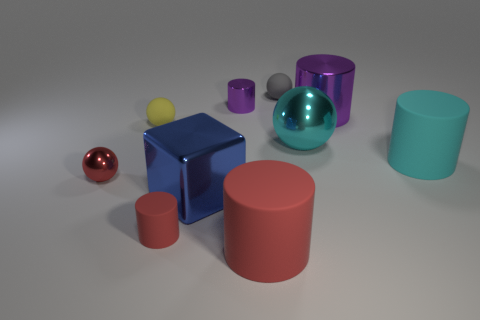Subtract all red cylinders. How many cylinders are left? 3 Subtract all big red cylinders. How many cylinders are left? 4 Subtract 1 balls. How many balls are left? 3 Subtract all brown cylinders. Subtract all gray spheres. How many cylinders are left? 5 Subtract all cyan balls. How many red cylinders are left? 2 Subtract all tiny red spheres. Subtract all tiny red metallic spheres. How many objects are left? 8 Add 3 purple things. How many purple things are left? 5 Add 1 small gray balls. How many small gray balls exist? 2 Subtract 1 red spheres. How many objects are left? 9 Subtract all cubes. How many objects are left? 9 